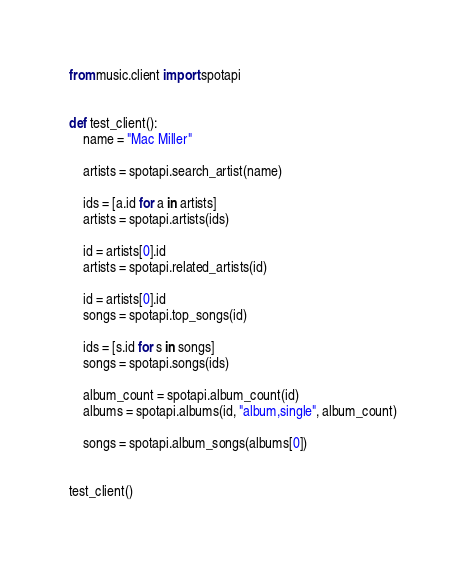Convert code to text. <code><loc_0><loc_0><loc_500><loc_500><_Python_>from music.client import spotapi


def test_client():
    name = "Mac Miller"

    artists = spotapi.search_artist(name)

    ids = [a.id for a in artists]
    artists = spotapi.artists(ids)

    id = artists[0].id
    artists = spotapi.related_artists(id)

    id = artists[0].id
    songs = spotapi.top_songs(id)

    ids = [s.id for s in songs]
    songs = spotapi.songs(ids)

    album_count = spotapi.album_count(id)
    albums = spotapi.albums(id, "album,single", album_count)

    songs = spotapi.album_songs(albums[0])


test_client()
</code> 